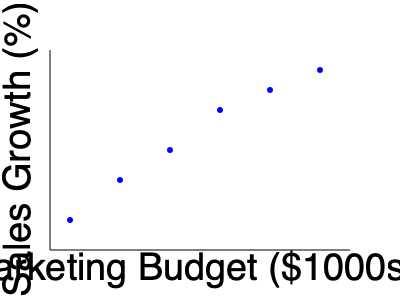As a business owner in a niche industry, you've been tracking the relationship between your marketing budget allocation and sales growth over the past six quarters. The scatter plot above represents this data. Based on the trend shown in the graph, what type of correlation exists between marketing budget and sales growth, and what might this imply for future budget decisions? To analyze the correlation between marketing budget allocation and sales growth, we need to follow these steps:

1. Observe the overall trend in the scatter plot:
   The points generally move from the lower left to the upper right of the graph.

2. Identify the correlation type:
   When points trend from lower left to upper right, it indicates a positive correlation.

3. Assess the strength of the correlation:
   The points form a relatively straight line with minimal scatter, suggesting a strong correlation.

4. Interpret the correlation:
   A strong positive correlation means that as the marketing budget increases, sales growth tends to increase as well.

5. Consider the implications:
   - There's a clear relationship between increased marketing spending and improved sales growth.
   - Each additional investment in marketing appears to yield positive returns in terms of sales growth.
   - The relationship seems consistent across the observed range of budget allocations.

6. Think about future budget decisions:
   - Increasing the marketing budget could potentially lead to further sales growth.
   - However, it's important to consider the law of diminishing returns, which isn't evident in this limited dataset.
   - The niche nature of the industry might affect how much additional growth can be achieved through marketing alone.

7. Formulate a conclusion:
   The strong positive correlation suggests that increasing the marketing budget has been effective in driving sales growth. Future budget decisions should consider this trend, but also account for other factors such as market saturation, competition, and overall business strategy.
Answer: Strong positive correlation; consider increasing marketing budget while monitoring for diminishing returns. 